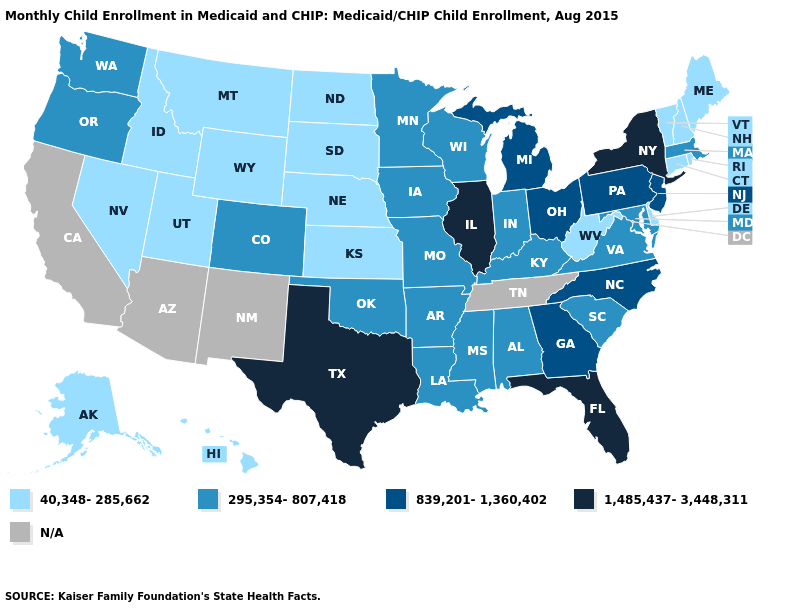Name the states that have a value in the range 40,348-285,662?
Give a very brief answer. Alaska, Connecticut, Delaware, Hawaii, Idaho, Kansas, Maine, Montana, Nebraska, Nevada, New Hampshire, North Dakota, Rhode Island, South Dakota, Utah, Vermont, West Virginia, Wyoming. Does Arkansas have the lowest value in the USA?
Quick response, please. No. How many symbols are there in the legend?
Give a very brief answer. 5. What is the lowest value in the USA?
Answer briefly. 40,348-285,662. Name the states that have a value in the range 295,354-807,418?
Answer briefly. Alabama, Arkansas, Colorado, Indiana, Iowa, Kentucky, Louisiana, Maryland, Massachusetts, Minnesota, Mississippi, Missouri, Oklahoma, Oregon, South Carolina, Virginia, Washington, Wisconsin. Which states have the lowest value in the Northeast?
Quick response, please. Connecticut, Maine, New Hampshire, Rhode Island, Vermont. What is the lowest value in the USA?
Short answer required. 40,348-285,662. Among the states that border Indiana , does Ohio have the highest value?
Write a very short answer. No. Does the first symbol in the legend represent the smallest category?
Keep it brief. Yes. What is the value of Tennessee?
Concise answer only. N/A. What is the value of New Jersey?
Short answer required. 839,201-1,360,402. What is the lowest value in states that border New Hampshire?
Keep it brief. 40,348-285,662. What is the lowest value in states that border Nevada?
Short answer required. 40,348-285,662. 